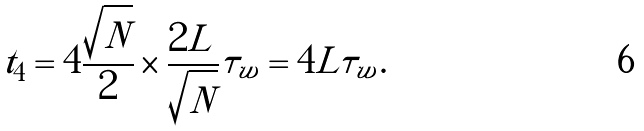<formula> <loc_0><loc_0><loc_500><loc_500>t _ { 4 } = 4 \frac { \sqrt { N } } { 2 } \times \frac { 2 L } { \sqrt { N } } \tau _ { w } = 4 L \tau _ { w } .</formula> 